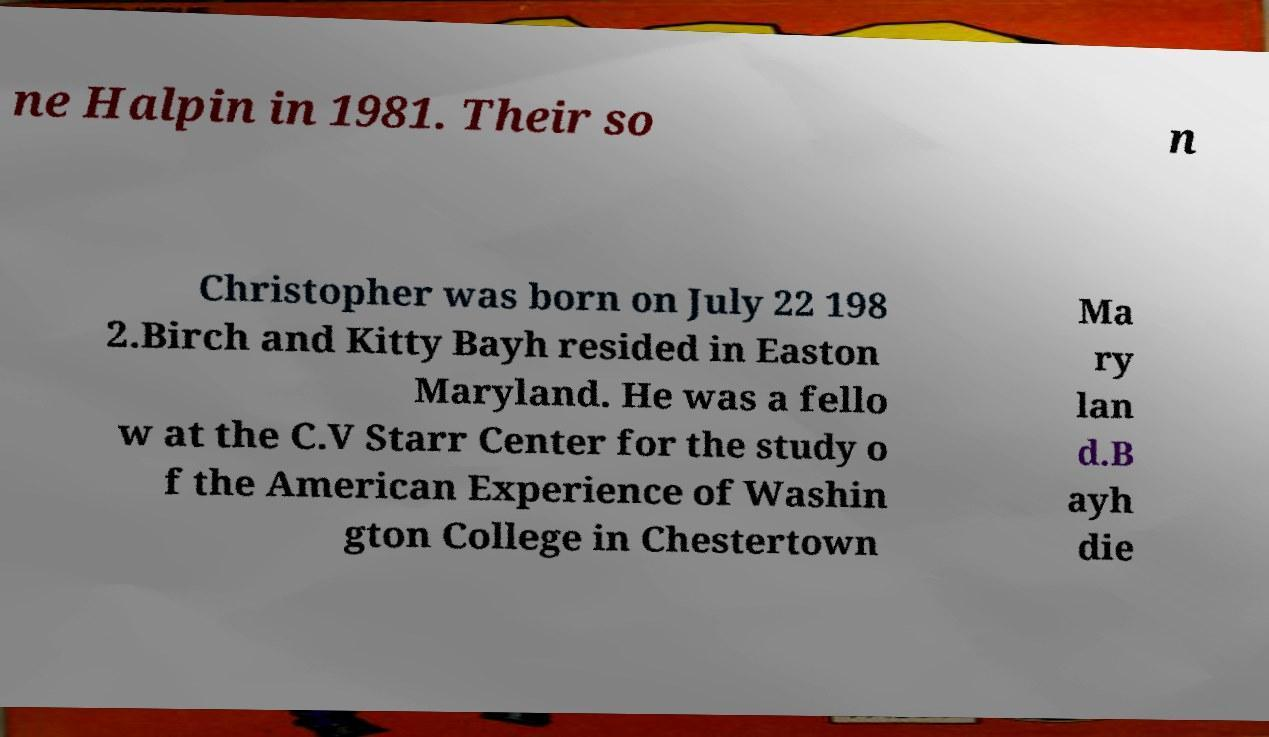What messages or text are displayed in this image? I need them in a readable, typed format. ne Halpin in 1981. Their so n Christopher was born on July 22 198 2.Birch and Kitty Bayh resided in Easton Maryland. He was a fello w at the C.V Starr Center for the study o f the American Experience of Washin gton College in Chestertown Ma ry lan d.B ayh die 